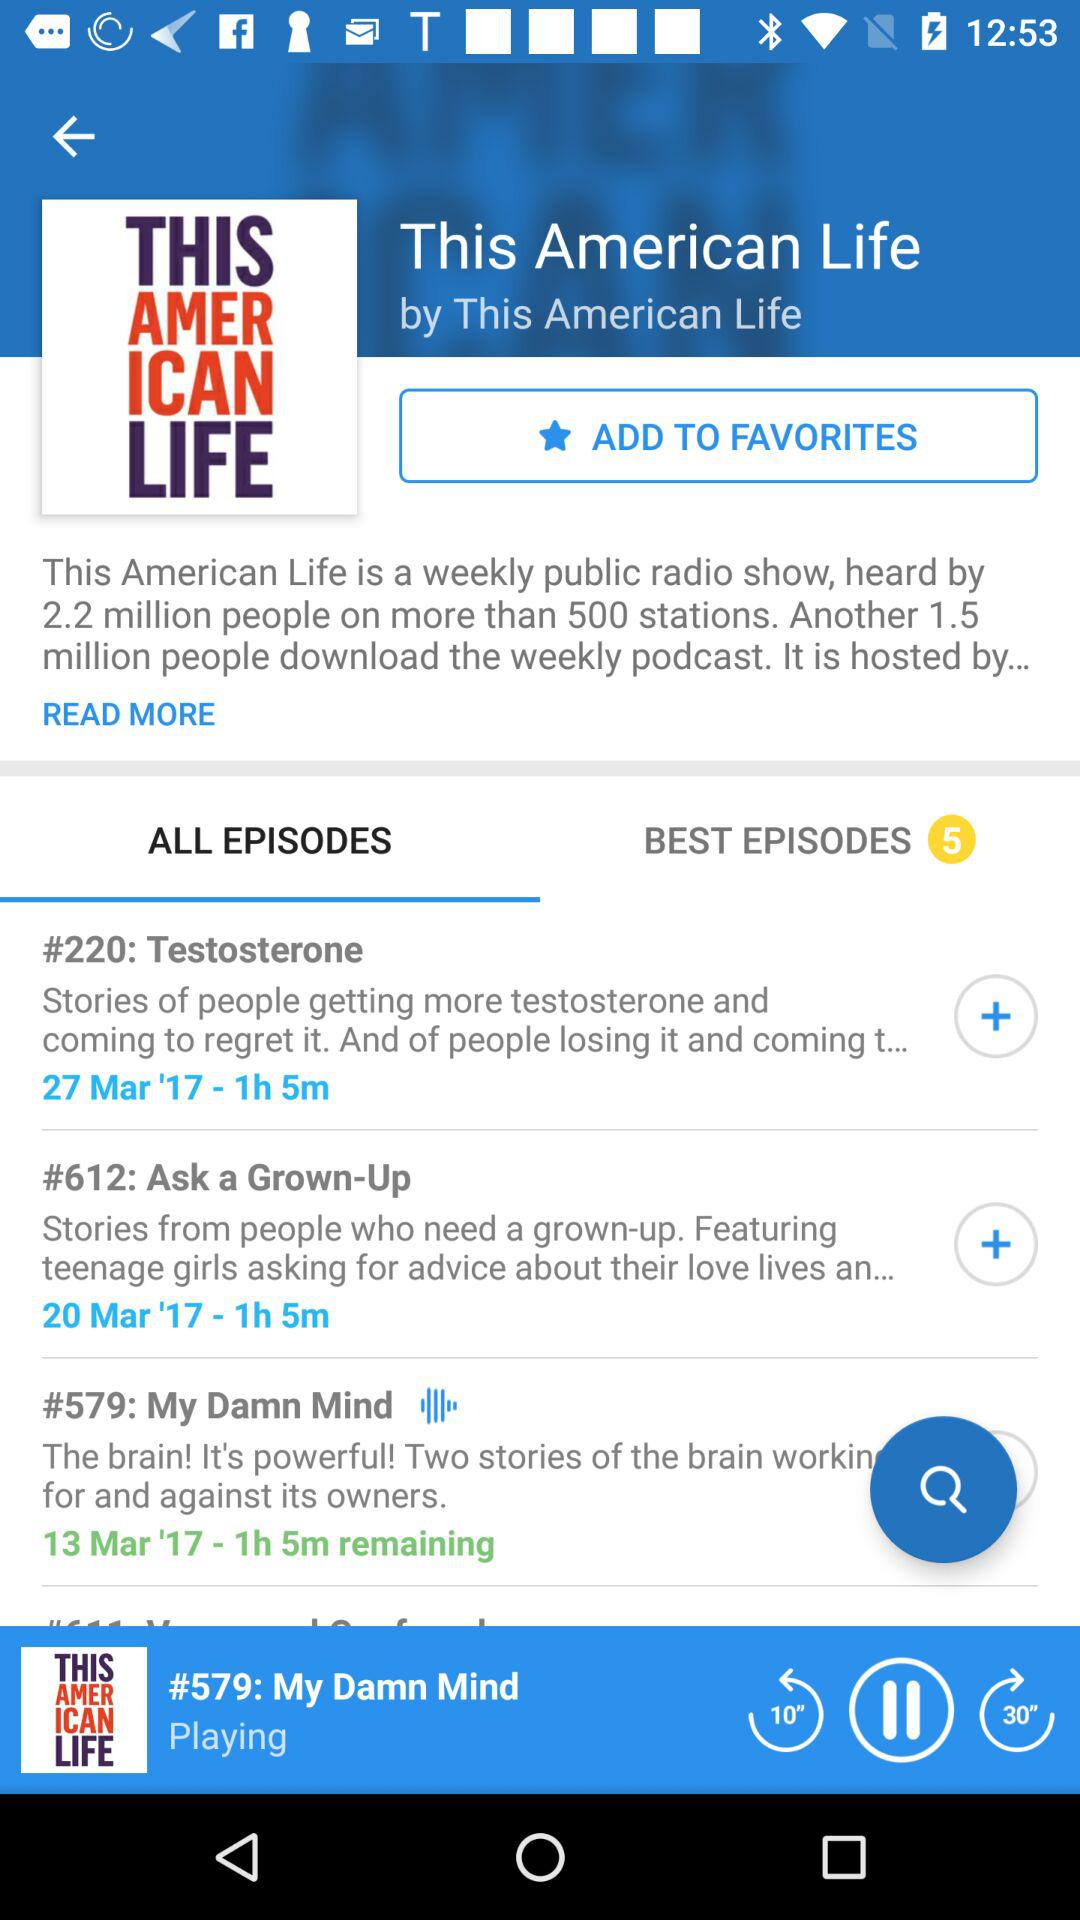What is the episode name that is currently playing? The episode that is currently playing is "My Damn Mind". 